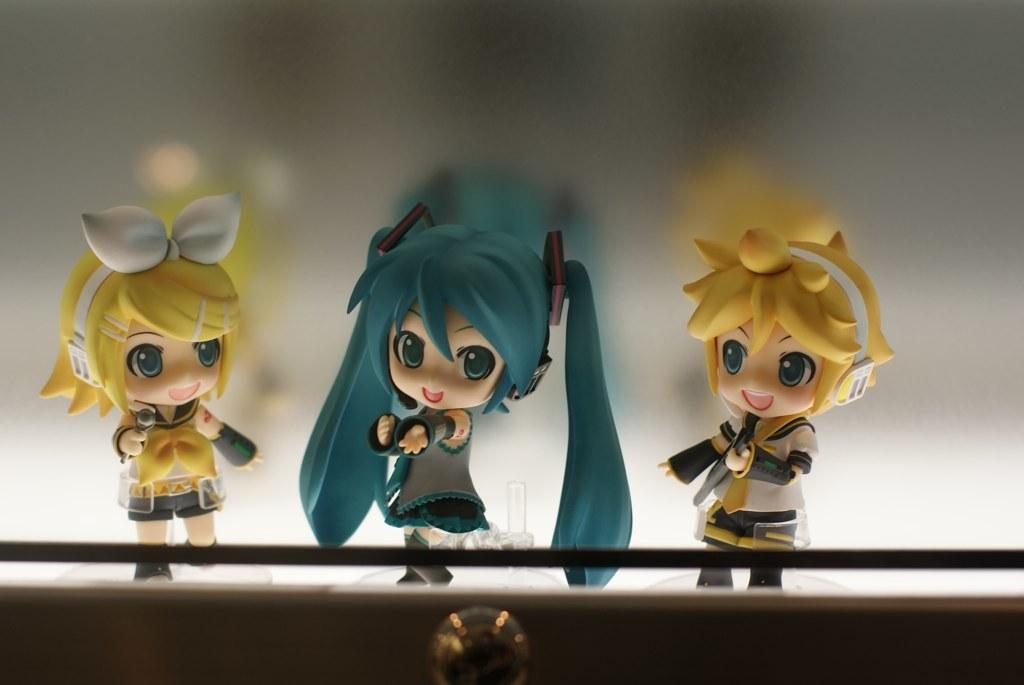What is the main subject of the image? The main subject of the image is three dolls in the center. What is the background of the image? There is a white surface behind the dolls. Are there any other objects or structures visible in the image? Yes, there appears to be a locker at the bottom of the image. What type of food is being prepared in the scene? There is no scene or food preparation visible in the image; it features three dolls and a locker. Can you describe the body language of the dolls in the image? The image does not show the dolls' body language, as they are stationary and not interacting with each other or their surroundings. 